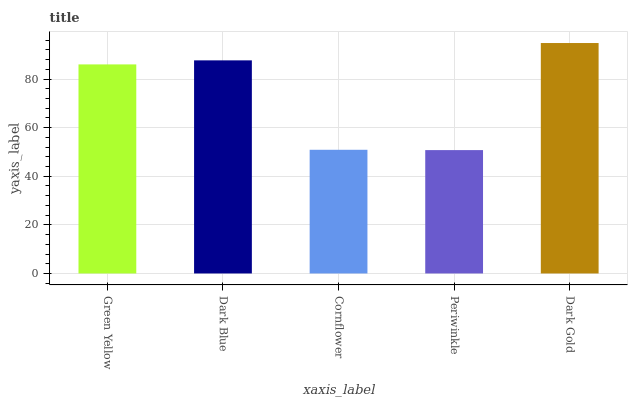Is Periwinkle the minimum?
Answer yes or no. Yes. Is Dark Gold the maximum?
Answer yes or no. Yes. Is Dark Blue the minimum?
Answer yes or no. No. Is Dark Blue the maximum?
Answer yes or no. No. Is Dark Blue greater than Green Yellow?
Answer yes or no. Yes. Is Green Yellow less than Dark Blue?
Answer yes or no. Yes. Is Green Yellow greater than Dark Blue?
Answer yes or no. No. Is Dark Blue less than Green Yellow?
Answer yes or no. No. Is Green Yellow the high median?
Answer yes or no. Yes. Is Green Yellow the low median?
Answer yes or no. Yes. Is Dark Blue the high median?
Answer yes or no. No. Is Periwinkle the low median?
Answer yes or no. No. 